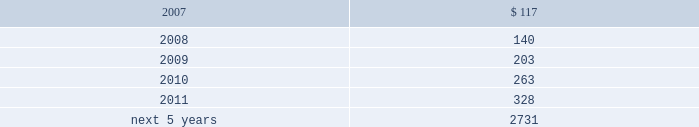The table displays the expected benefit payments in the years indicated : ( dollars in thousands ) .
1 4 .
D i v i d e n d r e s t r i c t i o n s a n d s t a t u t o r y f i n a n c i a l i n f o r m a t i o n a .
D i v i d e n d r e s t r i c t i o n s under bermuda law , group is prohibited from declaring or paying a dividend if such payment would reduce the realizable value of its assets to an amount less than the aggregate value of its liabilities and its issued share capital and share premium ( addi- tional paid-in capital ) accounts .
Group 2019s ability to pay dividends and its operating expenses is dependent upon dividends from its subsidiaries .
The payment of such dividends by insurer subsidiaries is limited under bermuda law and the laws of the var- ious u.s .
States in which group 2019s insurance and reinsurance subsidiaries are domiciled or deemed domiciled .
The limitations are generally based upon net income and compliance with applicable policyholders 2019 surplus or minimum solvency margin and liquidity ratio requirements as determined in accordance with the relevant statutory accounting practices .
Under bermuda law , bermuda re is prohibited from declaring or making payment of a dividend if it fails to meet its minimum solvency margin or minimum liquidity ratio .
As a long-term insurer , bermuda re is also unable to declare or pay a dividend to anyone who is not a policyholder unless , after payment of the dividend , the value of the assets in its long-term business fund , as certified by its approved actuary , exceeds its liabilities for long-term business by at least the $ 250000 minimum solvency margin .
Prior approval of the bermuda monetary authority is required if bermuda re 2019s dividend payments would reduce its prior year-end total statutory capital by 15.0% ( 15.0 % ) or more .
Delaware law provides that an insurance company which is a member of an insurance holding company system and is domi- ciled in the state shall not pay dividends without giving prior notice to the insurance commissioner of delaware and may not pay dividends without the approval of the insurance commissioner if the value of the proposed dividend , together with all other dividends and distributions made in the preceding twelve months , exceeds the greater of ( 1 ) 10% ( 10 % ) of statutory surplus or ( 2 ) net income , not including realized capital gains , each as reported in the prior year 2019s statutory annual statement .
In addition , no dividend may be paid in excess of unassigned earned surplus .
At december 31 , 2006 , everest re had $ 270.4 million available for payment of dividends in 2007 without the need for prior regulatory approval .
S t a t u t o r y f i n a n c i a l i n f o r m a t i o n everest re prepares its statutory financial statements in accordance with accounting practices prescribed or permitted by the national association of insurance commissioners ( 201cnaic 201d ) and the delaware insurance department .
Prescribed statutory accounting practices are set forth in the naic accounting practices and procedures manual .
The capital and statutory surplus of everest re was $ 2704.1 million ( unaudited ) and $ 2327.6 million at december 31 , 2006 and 2005 , respectively .
The statutory net income of everest re was $ 298.7 million ( unaudited ) for the year ended december 31 , 2006 , the statutory net loss was $ 26.9 million for the year ended december 31 , 2005 and the statutory net income $ 175.8 million for the year ended december 31 , 2004 .
Bermuda re prepares its statutory financial statements in conformity with the accounting principles set forth in bermuda in the insurance act 1978 , amendments thereto and related regulations .
The statutory capital and surplus of bermuda re was $ 1893.9 million ( unaudited ) and $ 1522.5 million at december 31 , 2006 and 2005 , respectively .
The statutory net income of bermuda re was $ 409.8 million ( unaudited ) for the year ended december 31 , 2006 , the statutory net loss was $ 220.5 million for the year ended december 31 , 2005 and the statutory net income was $ 248.7 million for the year ended december 31 , 2004 .
1 5 .
C o n t i n g e n c i e s in the ordinary course of business , the company is involved in lawsuits , arbitrations and other formal and informal dispute resolution procedures , the outcomes of which will determine the company 2019s rights and obligations under insurance , reinsur- ance and other contractual agreements .
In some disputes , the company seeks to enforce its rights under an agreement or to collect funds owing to it .
In other matters , the company is resisting attempts by others to collect funds or enforce alleged rights .
These disputes arise from time to time and as they arise are addressed , and ultimately resolved , through both informal and formal means , including negotiated resolution , arbitration and litigation .
In all such matters , the company believes that .
What is the percentage change in the capital and statutory surplus from 2005 to 2006? 
Computations: ((2704.1 - 2327.6) / 2327.6)
Answer: 0.16175. 